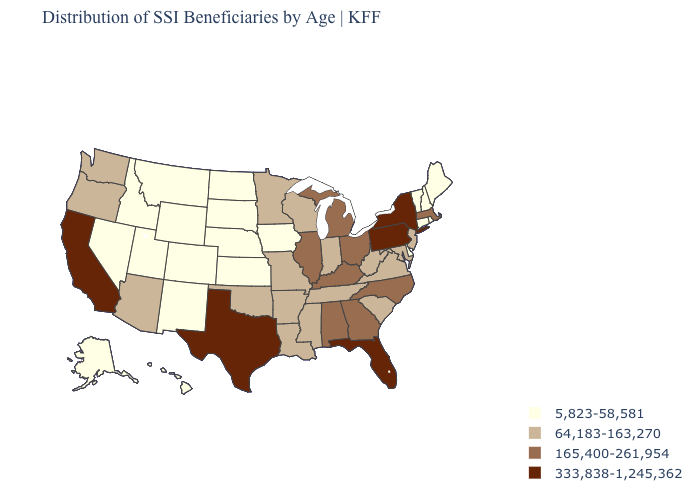What is the highest value in the Northeast ?
Give a very brief answer. 333,838-1,245,362. What is the value of South Dakota?
Keep it brief. 5,823-58,581. Among the states that border Michigan , which have the lowest value?
Answer briefly. Indiana, Wisconsin. Name the states that have a value in the range 165,400-261,954?
Answer briefly. Alabama, Georgia, Illinois, Kentucky, Massachusetts, Michigan, North Carolina, Ohio. What is the lowest value in the USA?
Be succinct. 5,823-58,581. Which states have the lowest value in the USA?
Keep it brief. Alaska, Colorado, Connecticut, Delaware, Hawaii, Idaho, Iowa, Kansas, Maine, Montana, Nebraska, Nevada, New Hampshire, New Mexico, North Dakota, Rhode Island, South Dakota, Utah, Vermont, Wyoming. What is the highest value in the USA?
Write a very short answer. 333,838-1,245,362. Name the states that have a value in the range 5,823-58,581?
Give a very brief answer. Alaska, Colorado, Connecticut, Delaware, Hawaii, Idaho, Iowa, Kansas, Maine, Montana, Nebraska, Nevada, New Hampshire, New Mexico, North Dakota, Rhode Island, South Dakota, Utah, Vermont, Wyoming. Among the states that border Nevada , does Utah have the lowest value?
Quick response, please. Yes. What is the value of Nebraska?
Short answer required. 5,823-58,581. Does Idaho have the highest value in the USA?
Answer briefly. No. What is the highest value in the Northeast ?
Quick response, please. 333,838-1,245,362. Does the first symbol in the legend represent the smallest category?
Write a very short answer. Yes. What is the value of North Dakota?
Be succinct. 5,823-58,581. What is the highest value in the MidWest ?
Write a very short answer. 165,400-261,954. 